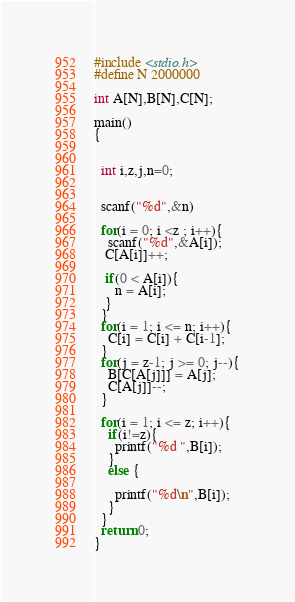Convert code to text. <code><loc_0><loc_0><loc_500><loc_500><_C_>#include <stdio.h>
#define N 2000000
  
int A[N],B[N],C[N];
 
main()
{
 
   
  int i,z,j,n=0;
   
   
  scanf("%d",&n)
   
  for(i = 0; i <z ; i++){
    scanf("%d",&A[i]);
   C[A[i]]++;
    
   if(0 < A[i]){
      n = A[i];
   }
  }
  for(i = 1; i <= n; i++){
    C[i] = C[i] + C[i-1];
  }
  for(j = z-1; j >= 0; j--){
    B[C[A[j]]] = A[j];
    C[A[j]]--;
  }
 
  for(i = 1; i <= z; i++){
    if(i!=z){
      printf("%d ",B[i]);
    }
    else {
       
      printf("%d\n",B[i]);
    }
  }
  return 0;
}</code> 